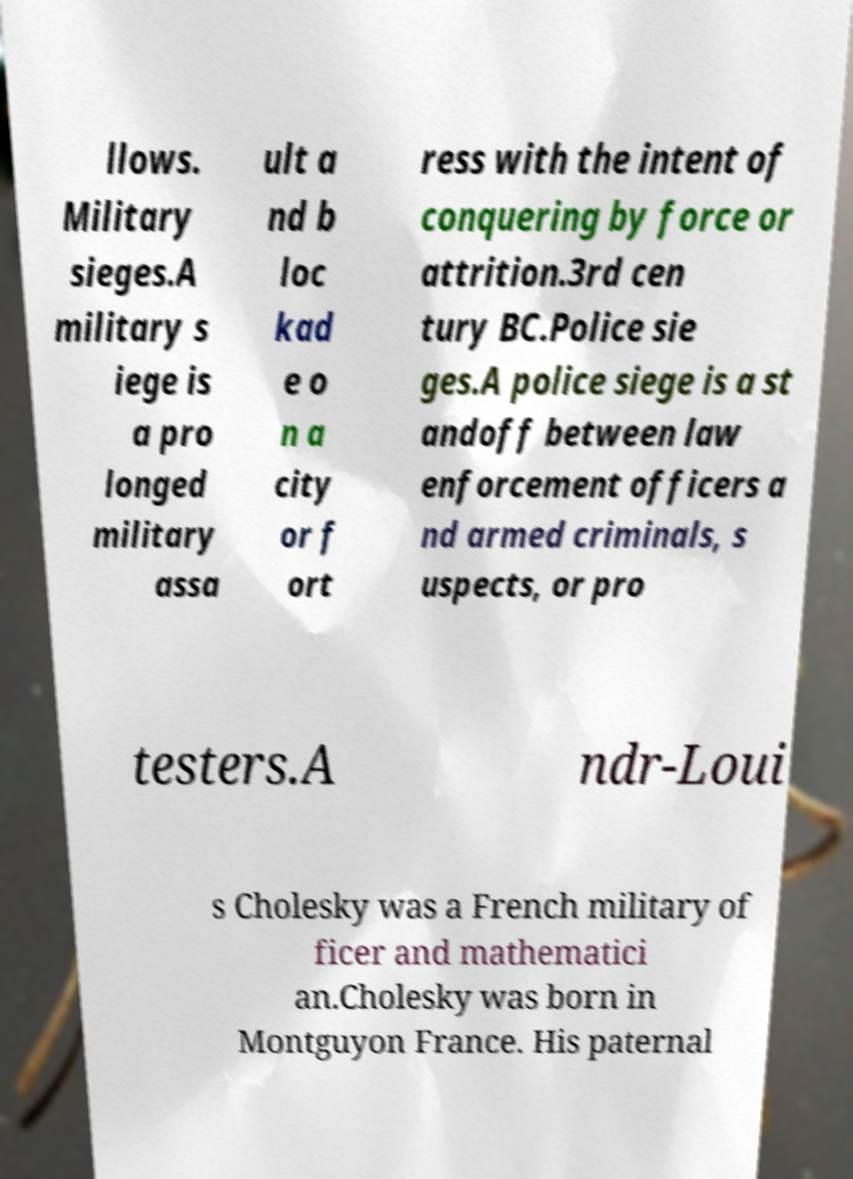What messages or text are displayed in this image? I need them in a readable, typed format. llows. Military sieges.A military s iege is a pro longed military assa ult a nd b loc kad e o n a city or f ort ress with the intent of conquering by force or attrition.3rd cen tury BC.Police sie ges.A police siege is a st andoff between law enforcement officers a nd armed criminals, s uspects, or pro testers.A ndr-Loui s Cholesky was a French military of ficer and mathematici an.Cholesky was born in Montguyon France. His paternal 